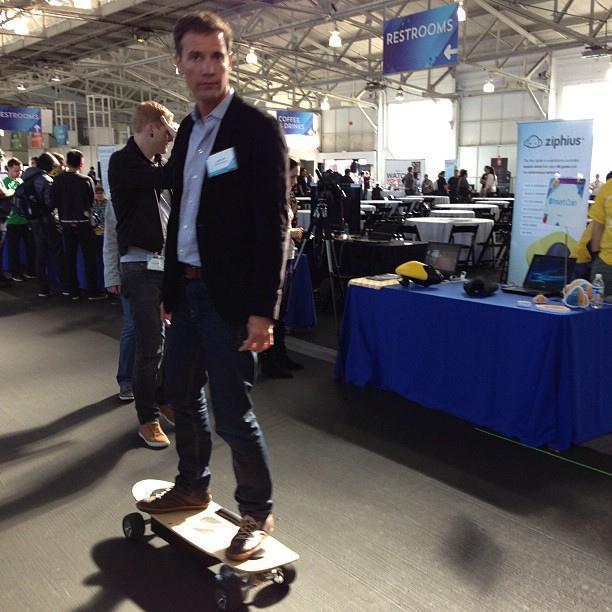How many people are there?
Give a very brief answer. 7. 